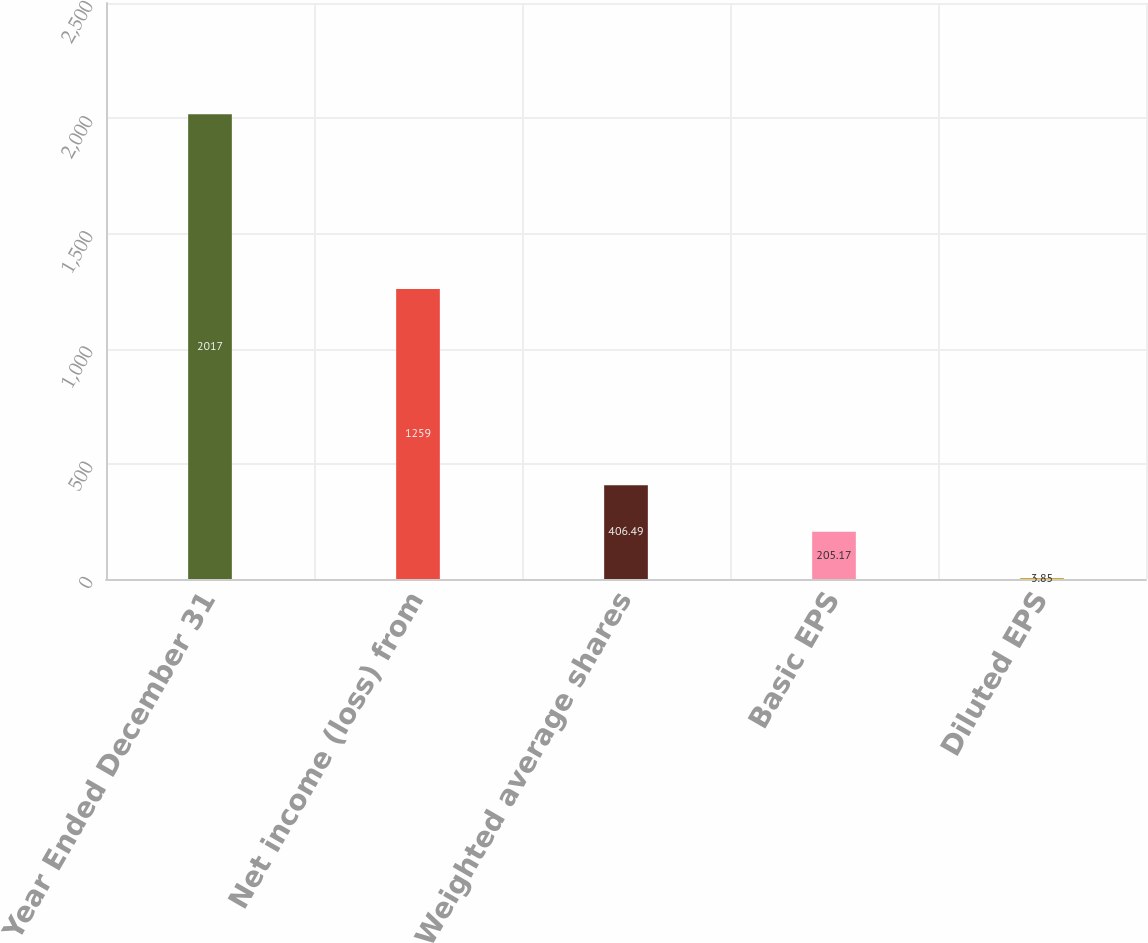<chart> <loc_0><loc_0><loc_500><loc_500><bar_chart><fcel>Year Ended December 31<fcel>Net income (loss) from<fcel>Weighted average shares<fcel>Basic EPS<fcel>Diluted EPS<nl><fcel>2017<fcel>1259<fcel>406.49<fcel>205.17<fcel>3.85<nl></chart> 